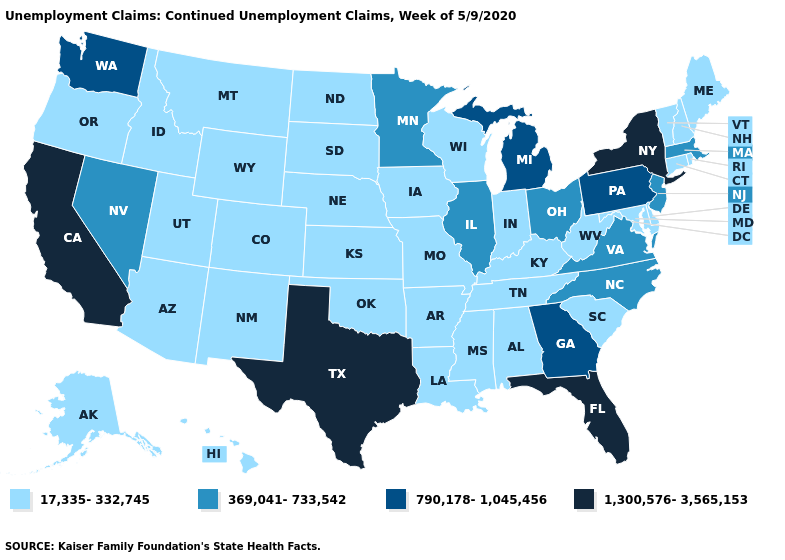Does Oregon have a lower value than Michigan?
Give a very brief answer. Yes. Does the first symbol in the legend represent the smallest category?
Write a very short answer. Yes. Name the states that have a value in the range 17,335-332,745?
Quick response, please. Alabama, Alaska, Arizona, Arkansas, Colorado, Connecticut, Delaware, Hawaii, Idaho, Indiana, Iowa, Kansas, Kentucky, Louisiana, Maine, Maryland, Mississippi, Missouri, Montana, Nebraska, New Hampshire, New Mexico, North Dakota, Oklahoma, Oregon, Rhode Island, South Carolina, South Dakota, Tennessee, Utah, Vermont, West Virginia, Wisconsin, Wyoming. Does the first symbol in the legend represent the smallest category?
Answer briefly. Yes. Among the states that border Virginia , which have the lowest value?
Be succinct. Kentucky, Maryland, Tennessee, West Virginia. Name the states that have a value in the range 1,300,576-3,565,153?
Answer briefly. California, Florida, New York, Texas. Name the states that have a value in the range 1,300,576-3,565,153?
Short answer required. California, Florida, New York, Texas. What is the value of New York?
Short answer required. 1,300,576-3,565,153. Which states have the highest value in the USA?
Answer briefly. California, Florida, New York, Texas. Among the states that border Nevada , which have the highest value?
Give a very brief answer. California. Name the states that have a value in the range 790,178-1,045,456?
Keep it brief. Georgia, Michigan, Pennsylvania, Washington. Does Illinois have the same value as Nevada?
Answer briefly. Yes. Does the first symbol in the legend represent the smallest category?
Short answer required. Yes. Does Georgia have the lowest value in the South?
Short answer required. No. Does Nevada have the highest value in the USA?
Quick response, please. No. 